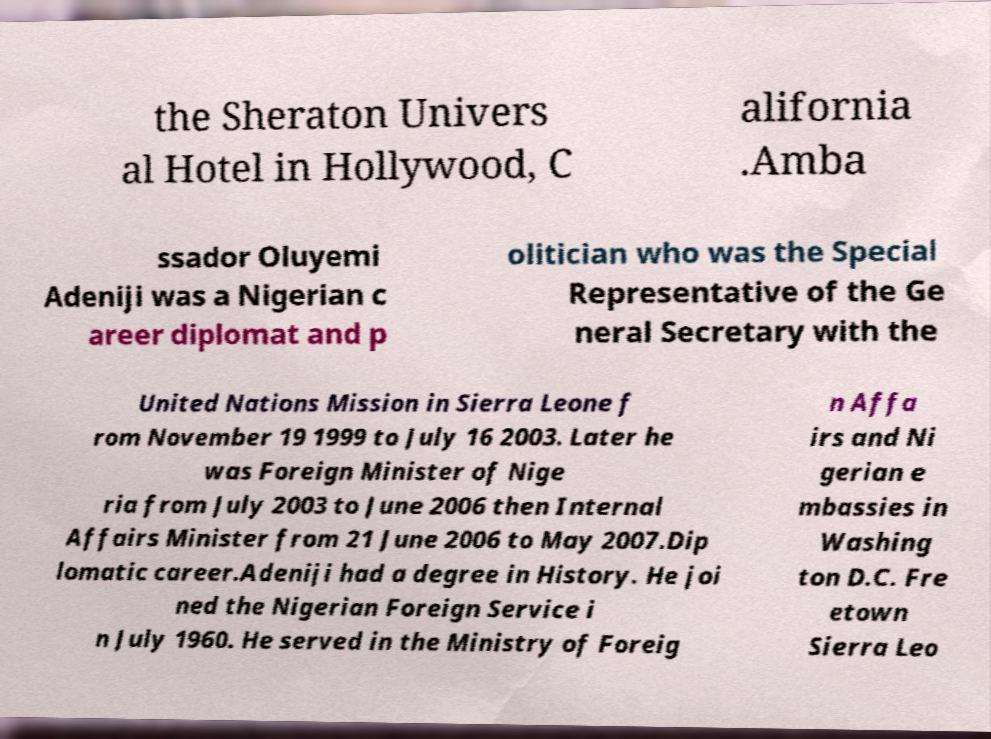Can you read and provide the text displayed in the image?This photo seems to have some interesting text. Can you extract and type it out for me? the Sheraton Univers al Hotel in Hollywood, C alifornia .Amba ssador Oluyemi Adeniji was a Nigerian c areer diplomat and p olitician who was the Special Representative of the Ge neral Secretary with the United Nations Mission in Sierra Leone f rom November 19 1999 to July 16 2003. Later he was Foreign Minister of Nige ria from July 2003 to June 2006 then Internal Affairs Minister from 21 June 2006 to May 2007.Dip lomatic career.Adeniji had a degree in History. He joi ned the Nigerian Foreign Service i n July 1960. He served in the Ministry of Foreig n Affa irs and Ni gerian e mbassies in Washing ton D.C. Fre etown Sierra Leo 